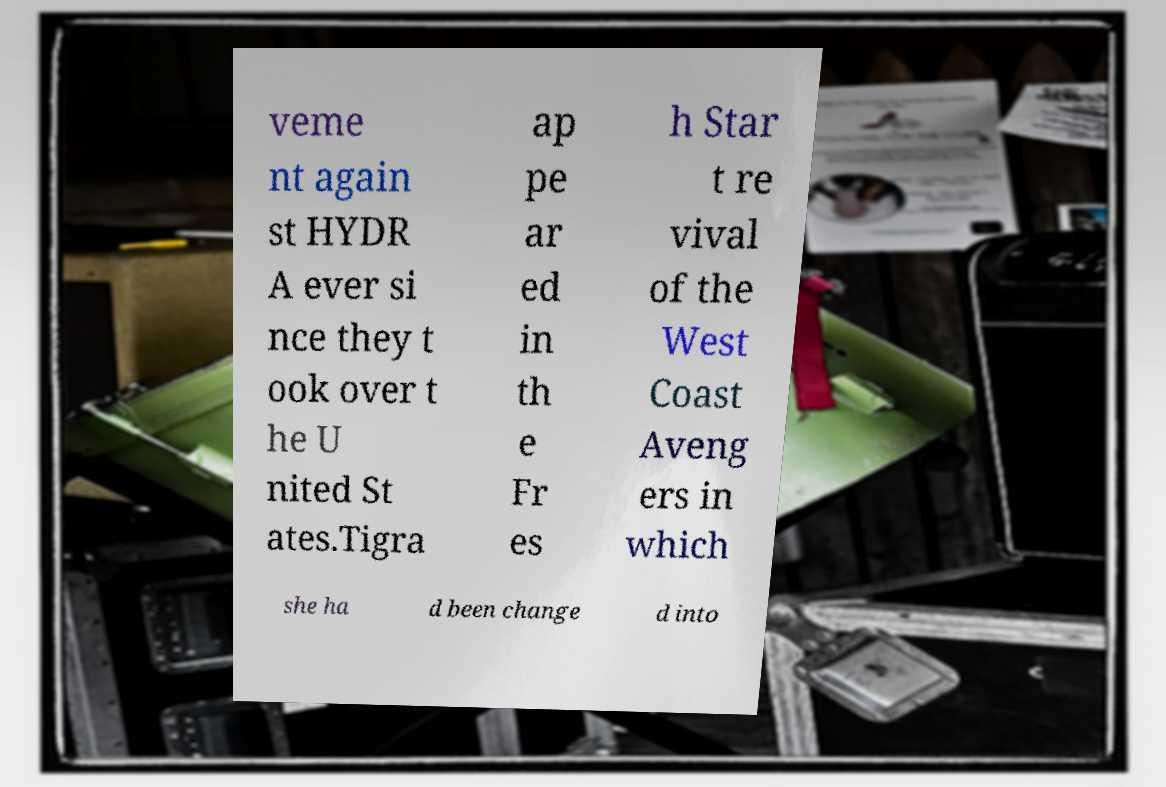Could you extract and type out the text from this image? veme nt again st HYDR A ever si nce they t ook over t he U nited St ates.Tigra ap pe ar ed in th e Fr es h Star t re vival of the West Coast Aveng ers in which she ha d been change d into 